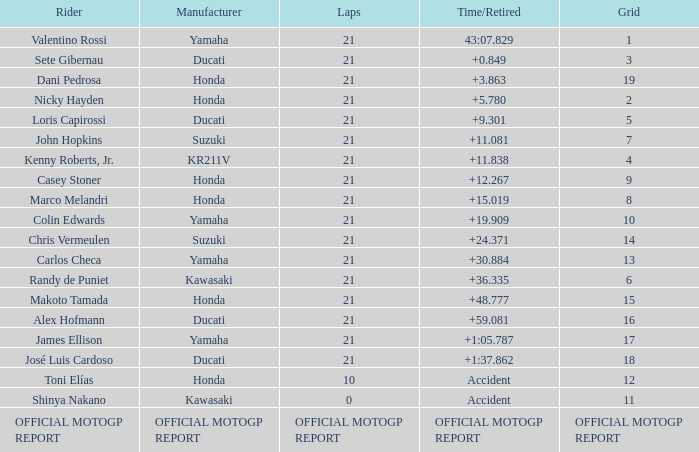What is the time/retired for the rider with the manufacturuer yamaha, grod of 1 and 21 total laps? 43:07.829. 